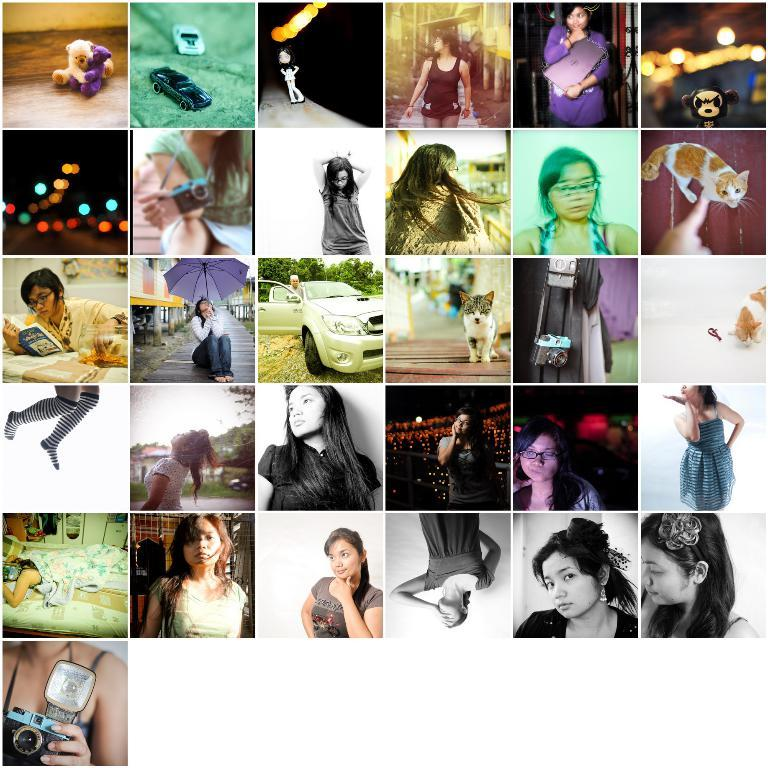Who or what can be seen in the image? There are people, toys, vehicles, and cats in the image. Can you describe the toys in the image? Unfortunately, the facts provided do not give specific details about the toys. What types of vehicles are visible in the image? The facts provided do not specify the types of vehicles in the image. How many cats are in the image? The facts provided do not specify the number of cats in the image. What songs are being sung by the cats in the image? There are no cats singing songs in the image, as the facts provided do not mention any singing or music. 